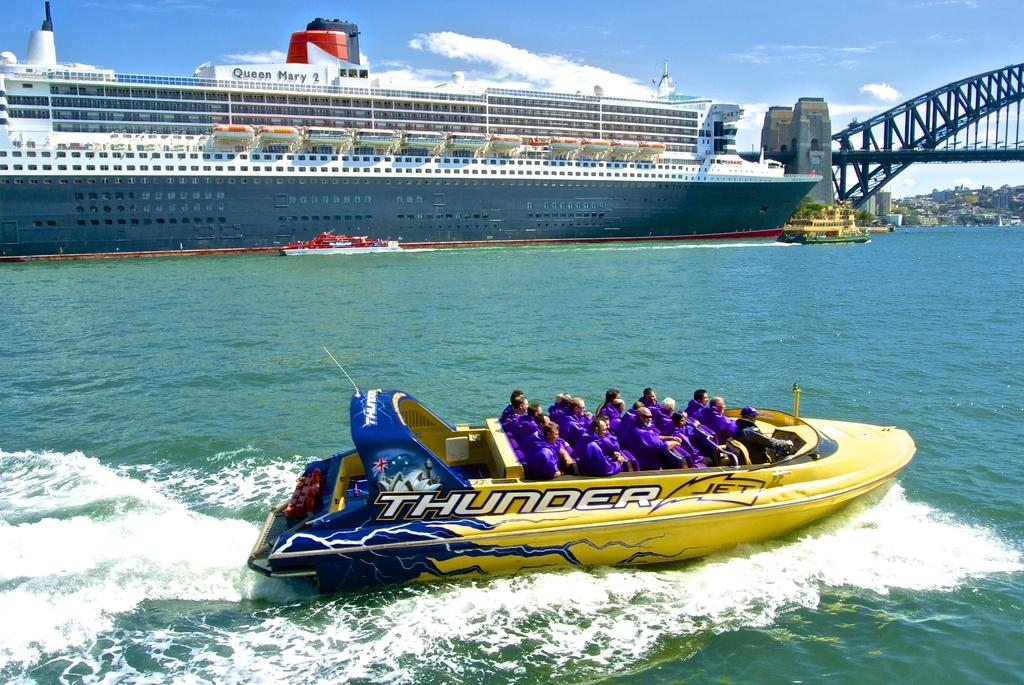Provide a one-sentence caption for the provided image. A big yellow boat named Thunder Jet goes across the water carrying many people in blue shirts. 